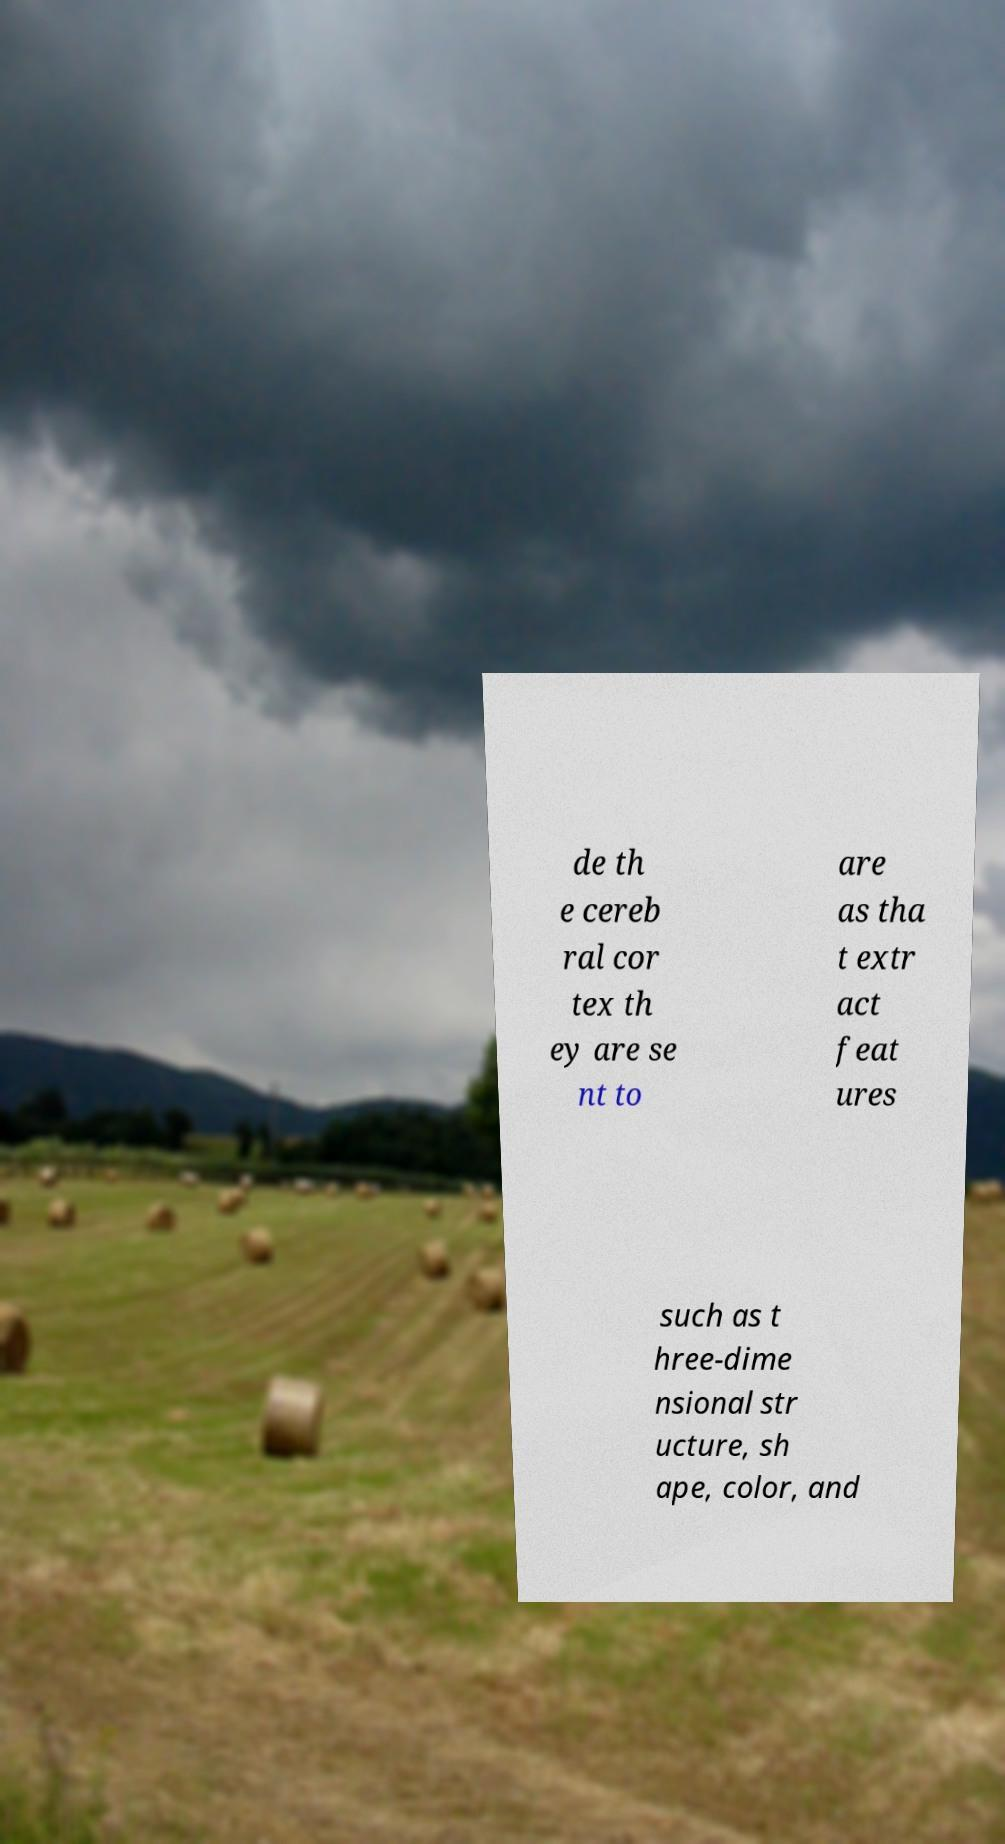Can you accurately transcribe the text from the provided image for me? de th e cereb ral cor tex th ey are se nt to are as tha t extr act feat ures such as t hree-dime nsional str ucture, sh ape, color, and 